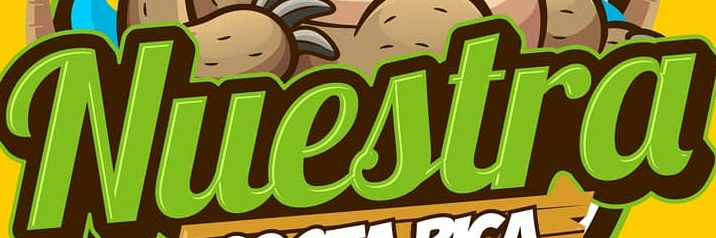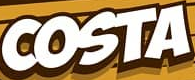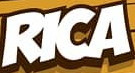Read the text from these images in sequence, separated by a semicolon. Nuestra; COSTA; RICA 